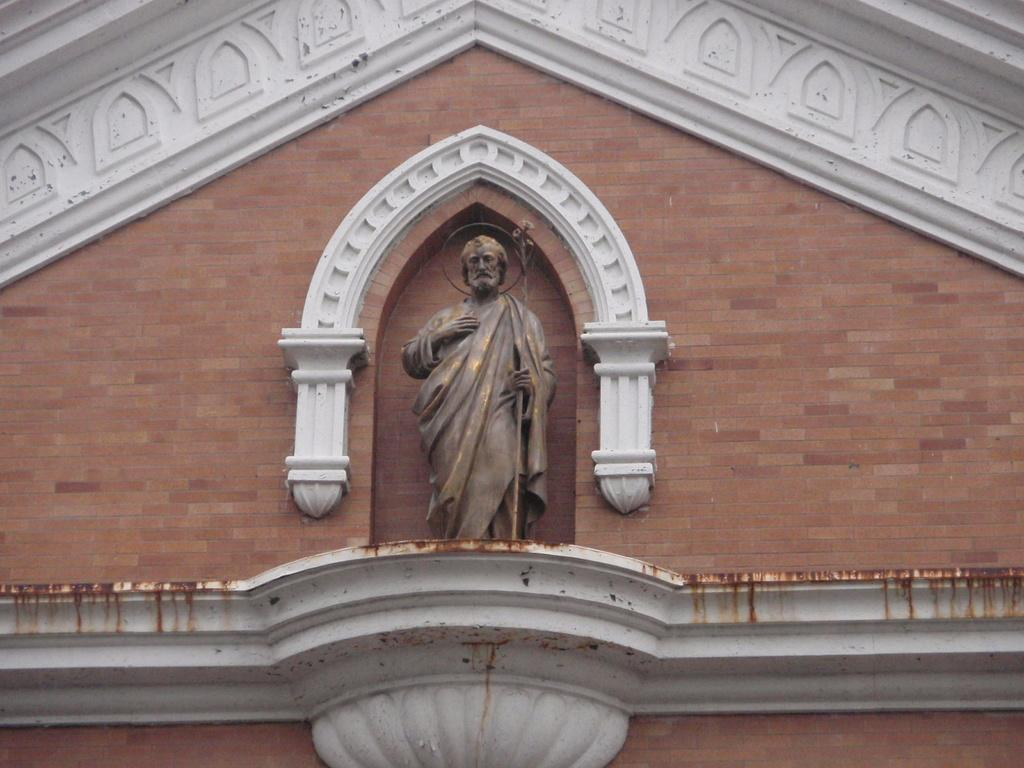What type of structure is visible in the image? There is a building in the image. What additional object can be seen in the image? There is a statue in the image. What architectural feature is present in the image? There is a wall in the image. What book is the statue holding in the image? There is no book present in the image; the statue is not holding anything. Can you describe the twig that is leaning against the wall in the image? There is no twig present in the image; the wall is clear of any such objects. 